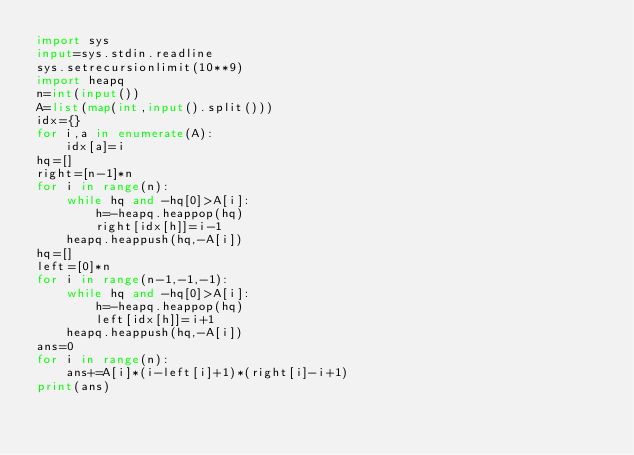<code> <loc_0><loc_0><loc_500><loc_500><_Python_>import sys
input=sys.stdin.readline
sys.setrecursionlimit(10**9)
import heapq
n=int(input())
A=list(map(int,input().split()))
idx={}
for i,a in enumerate(A):
    idx[a]=i
hq=[]
right=[n-1]*n
for i in range(n):
    while hq and -hq[0]>A[i]:
        h=-heapq.heappop(hq)
        right[idx[h]]=i-1
    heapq.heappush(hq,-A[i])
hq=[]
left=[0]*n
for i in range(n-1,-1,-1):
    while hq and -hq[0]>A[i]:
        h=-heapq.heappop(hq)
        left[idx[h]]=i+1
    heapq.heappush(hq,-A[i])
ans=0
for i in range(n):
    ans+=A[i]*(i-left[i]+1)*(right[i]-i+1)
print(ans)</code> 